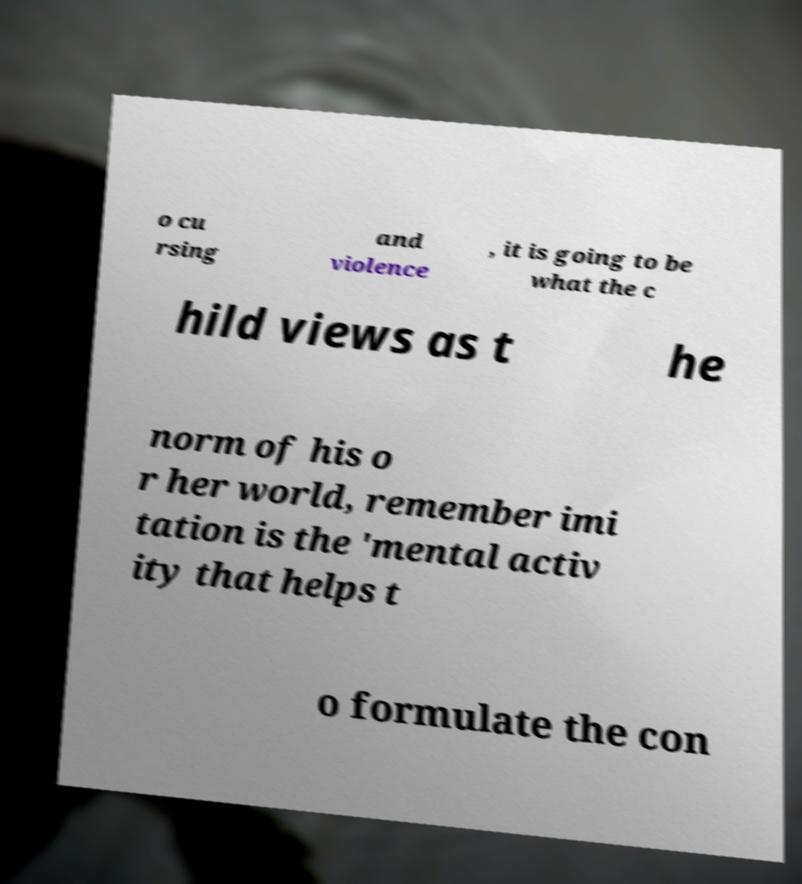Could you extract and type out the text from this image? o cu rsing and violence , it is going to be what the c hild views as t he norm of his o r her world, remember imi tation is the 'mental activ ity that helps t o formulate the con 